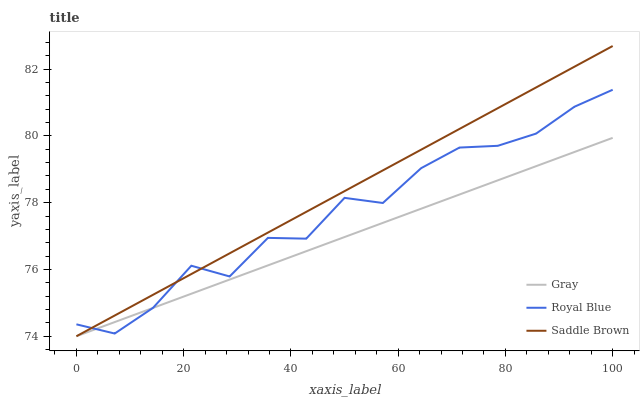Does Gray have the minimum area under the curve?
Answer yes or no. Yes. Does Saddle Brown have the maximum area under the curve?
Answer yes or no. Yes. Does Royal Blue have the minimum area under the curve?
Answer yes or no. No. Does Royal Blue have the maximum area under the curve?
Answer yes or no. No. Is Gray the smoothest?
Answer yes or no. Yes. Is Royal Blue the roughest?
Answer yes or no. Yes. Is Saddle Brown the smoothest?
Answer yes or no. No. Is Saddle Brown the roughest?
Answer yes or no. No. Does Royal Blue have the lowest value?
Answer yes or no. No. Does Saddle Brown have the highest value?
Answer yes or no. Yes. Does Royal Blue have the highest value?
Answer yes or no. No. Does Saddle Brown intersect Gray?
Answer yes or no. Yes. Is Saddle Brown less than Gray?
Answer yes or no. No. Is Saddle Brown greater than Gray?
Answer yes or no. No. 